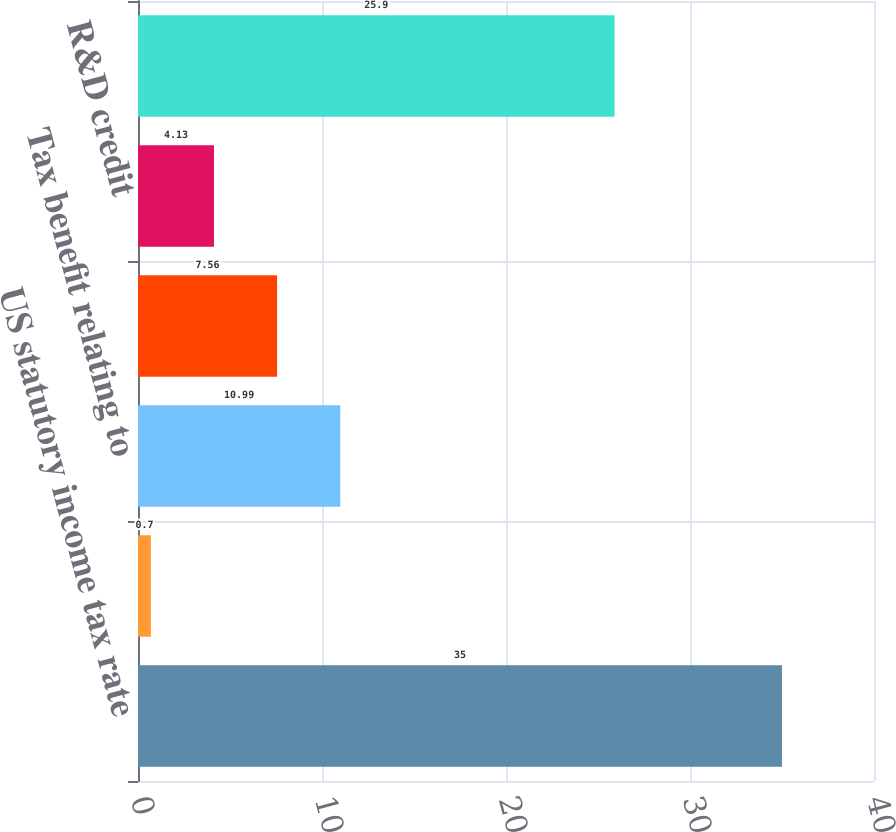Convert chart to OTSL. <chart><loc_0><loc_0><loc_500><loc_500><bar_chart><fcel>US statutory income tax rate<fcel>State taxes net of federal<fcel>Tax benefit relating to<fcel>Tax benefit relating to US<fcel>R&D credit<fcel>Effective income tax rate<nl><fcel>35<fcel>0.7<fcel>10.99<fcel>7.56<fcel>4.13<fcel>25.9<nl></chart> 